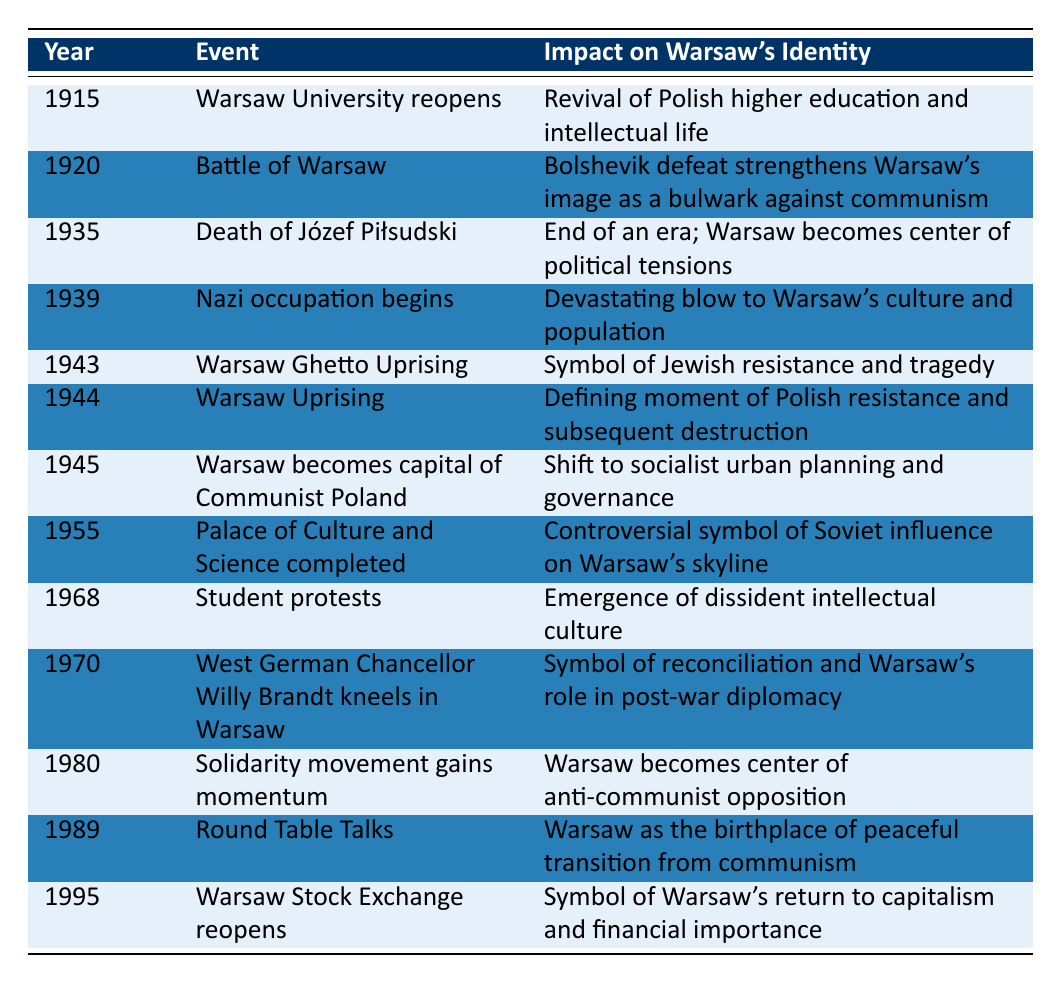What event took place in 1944? The table lists the event in 1944 as the "Warsaw Uprising." By finding the year in the table and looking at the corresponding event in the second column, we can identify it directly.
Answer: Warsaw Uprising What was the impact of the Battle of Warsaw on Warsaw's identity? The table states that the impact was that the Bolshevik defeat strengthens Warsaw's image as a bulwark against communism. This is found by locating the entry for 1920 in the table and reading the related impact in the third column.
Answer: Bolshevik defeat strengthens Warsaw's image as a bulwark against communism How many major events are listed that occurred during the 1940s? By reviewing the table, we can count the events for the years 1939 to 1945, which includes four events: Nazi occupation begins, Warsaw Ghetto Uprising, Warsaw Uprising, and Warsaw becomes capital of Communist Poland. Thus, the total is 4.
Answer: 4 Was the completion of the Palace of Culture and Science seen as a positive event for Warsaw? The entry for 1955 describes the Palace of Culture and Science as a "controversial symbol of Soviet influence," indicating mixed feelings. Since it is labeled as controversial, we can infer that it was not universally seen as positive.
Answer: No Which two events in the 1980s significantly influenced Warsaw's identity? The table lists two major events in the 1980s: "Solidarity movement gains momentum" in 1980 and "Round Table Talks" in 1989. We find these events in the respective years and note their significance to Warsaw's identity.
Answer: Solidarity movement gains momentum and Round Table Talks What was the impact on Warsaw's identity following the death of Józef Piłsudski? According to the table in the 1935 entry, the impact was that Warsaw became the center of political tensions, signifying a shift in the political landscape. This fact can be confirmed by reading the impact statement related to that event.
Answer: Warsaw becomes center of political tensions Which event is associated with the year 1989? The table specifies that the event for 1989 is "Round Table Talks." This event can be found directly in the row for that year.
Answer: Round Table Talks What impact did the Warsaw Stock Exchange reopening in 1995 have on the identity of Warsaw? The entry for 1995 indicates that it was a symbol of Warsaw's return to capitalism and financial importance. This is found by checking the details in the corresponding row for that year.
Answer: Symbol of Warsaw's return to capitalism and financial importance 